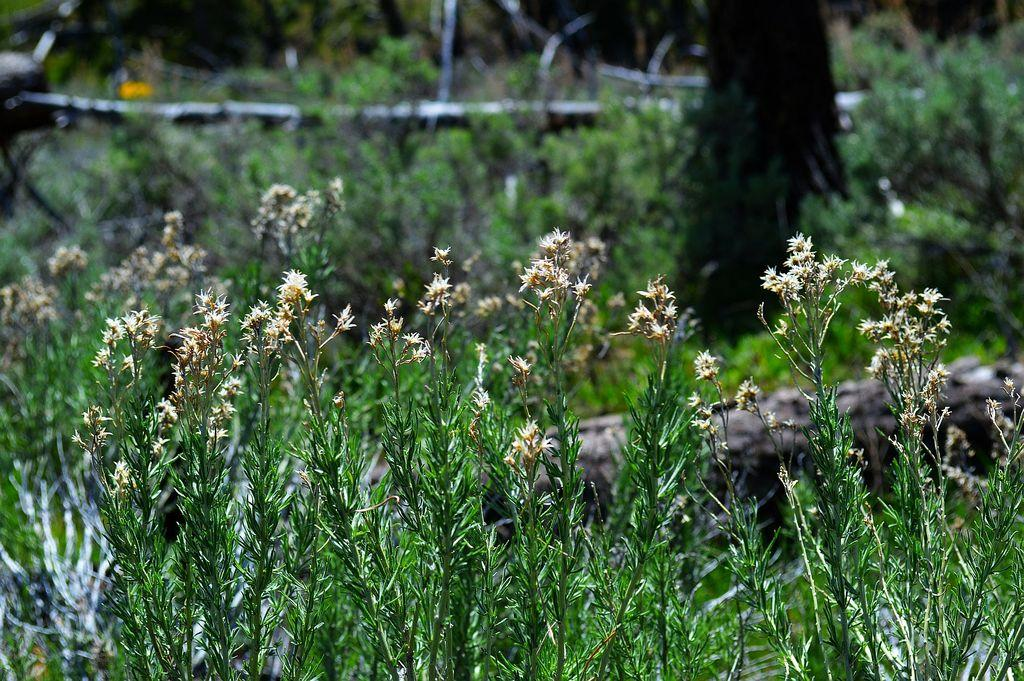What type of plants are at the bottom of the image? There are plants with flowers at the bottom of the image. What is located behind the plants on the right side? There is a trunk behind the plants on the right side. What can be seen in the background of the image? There are many plants and trunks visible in the background of the image. How many matches are being used to light the candles on the birthday cake in the image? There is no birthday cake or candles present in the image, so it is not possible to determine how many matches might be used. 